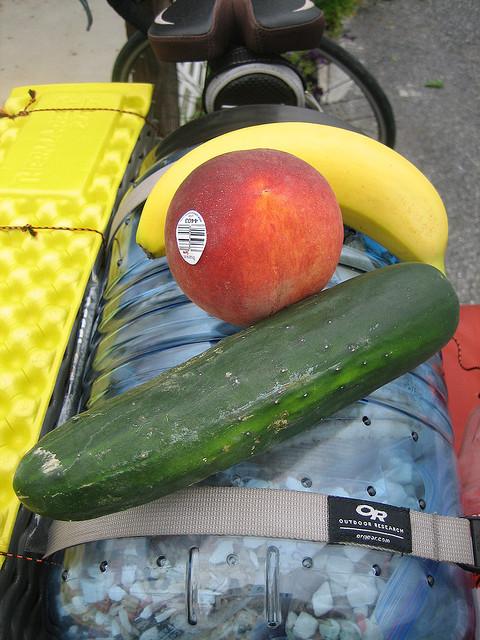Are all three pieces of food classified as fruit?
Give a very brief answer. No. What is the green object called?
Write a very short answer. Cucumber. Which is not a fruit?
Answer briefly. Cucumber. 